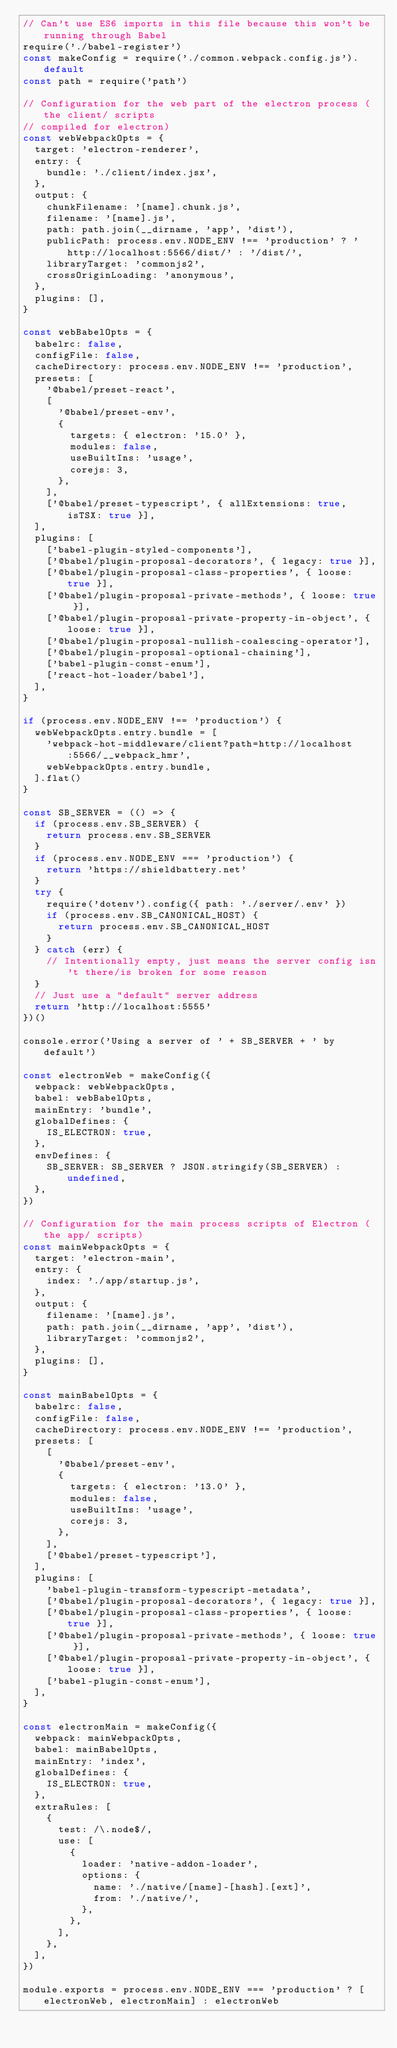<code> <loc_0><loc_0><loc_500><loc_500><_JavaScript_>// Can't use ES6 imports in this file because this won't be running through Babel
require('./babel-register')
const makeConfig = require('./common.webpack.config.js').default
const path = require('path')

// Configuration for the web part of the electron process (the client/ scripts
// compiled for electron)
const webWebpackOpts = {
  target: 'electron-renderer',
  entry: {
    bundle: './client/index.jsx',
  },
  output: {
    chunkFilename: '[name].chunk.js',
    filename: '[name].js',
    path: path.join(__dirname, 'app', 'dist'),
    publicPath: process.env.NODE_ENV !== 'production' ? 'http://localhost:5566/dist/' : '/dist/',
    libraryTarget: 'commonjs2',
    crossOriginLoading: 'anonymous',
  },
  plugins: [],
}

const webBabelOpts = {
  babelrc: false,
  configFile: false,
  cacheDirectory: process.env.NODE_ENV !== 'production',
  presets: [
    '@babel/preset-react',
    [
      '@babel/preset-env',
      {
        targets: { electron: '15.0' },
        modules: false,
        useBuiltIns: 'usage',
        corejs: 3,
      },
    ],
    ['@babel/preset-typescript', { allExtensions: true, isTSX: true }],
  ],
  plugins: [
    ['babel-plugin-styled-components'],
    ['@babel/plugin-proposal-decorators', { legacy: true }],
    ['@babel/plugin-proposal-class-properties', { loose: true }],
    ['@babel/plugin-proposal-private-methods', { loose: true }],
    ['@babel/plugin-proposal-private-property-in-object', { loose: true }],
    ['@babel/plugin-proposal-nullish-coalescing-operator'],
    ['@babel/plugin-proposal-optional-chaining'],
    ['babel-plugin-const-enum'],
    ['react-hot-loader/babel'],
  ],
}

if (process.env.NODE_ENV !== 'production') {
  webWebpackOpts.entry.bundle = [
    'webpack-hot-middleware/client?path=http://localhost:5566/__webpack_hmr',
    webWebpackOpts.entry.bundle,
  ].flat()
}

const SB_SERVER = (() => {
  if (process.env.SB_SERVER) {
    return process.env.SB_SERVER
  }
  if (process.env.NODE_ENV === 'production') {
    return 'https://shieldbattery.net'
  }
  try {
    require('dotenv').config({ path: './server/.env' })
    if (process.env.SB_CANONICAL_HOST) {
      return process.env.SB_CANONICAL_HOST
    }
  } catch (err) {
    // Intentionally empty, just means the server config isn't there/is broken for some reason
  }
  // Just use a "default" server address
  return 'http://localhost:5555'
})()

console.error('Using a server of ' + SB_SERVER + ' by default')

const electronWeb = makeConfig({
  webpack: webWebpackOpts,
  babel: webBabelOpts,
  mainEntry: 'bundle',
  globalDefines: {
    IS_ELECTRON: true,
  },
  envDefines: {
    SB_SERVER: SB_SERVER ? JSON.stringify(SB_SERVER) : undefined,
  },
})

// Configuration for the main process scripts of Electron (the app/ scripts)
const mainWebpackOpts = {
  target: 'electron-main',
  entry: {
    index: './app/startup.js',
  },
  output: {
    filename: '[name].js',
    path: path.join(__dirname, 'app', 'dist'),
    libraryTarget: 'commonjs2',
  },
  plugins: [],
}

const mainBabelOpts = {
  babelrc: false,
  configFile: false,
  cacheDirectory: process.env.NODE_ENV !== 'production',
  presets: [
    [
      '@babel/preset-env',
      {
        targets: { electron: '13.0' },
        modules: false,
        useBuiltIns: 'usage',
        corejs: 3,
      },
    ],
    ['@babel/preset-typescript'],
  ],
  plugins: [
    'babel-plugin-transform-typescript-metadata',
    ['@babel/plugin-proposal-decorators', { legacy: true }],
    ['@babel/plugin-proposal-class-properties', { loose: true }],
    ['@babel/plugin-proposal-private-methods', { loose: true }],
    ['@babel/plugin-proposal-private-property-in-object', { loose: true }],
    ['babel-plugin-const-enum'],
  ],
}

const electronMain = makeConfig({
  webpack: mainWebpackOpts,
  babel: mainBabelOpts,
  mainEntry: 'index',
  globalDefines: {
    IS_ELECTRON: true,
  },
  extraRules: [
    {
      test: /\.node$/,
      use: [
        {
          loader: 'native-addon-loader',
          options: {
            name: './native/[name]-[hash].[ext]',
            from: './native/',
          },
        },
      ],
    },
  ],
})

module.exports = process.env.NODE_ENV === 'production' ? [electronWeb, electronMain] : electronWeb
</code> 